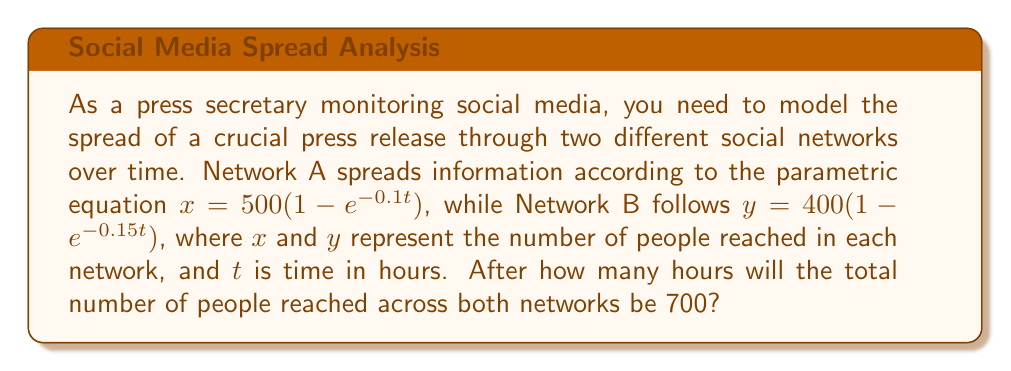Show me your answer to this math problem. To solve this problem, we need to follow these steps:

1) The total number of people reached is the sum of people reached in both networks:
   $x + y = 700$

2) Substitute the parametric equations:
   $500(1-e^{-0.1t}) + 400(1-e^{-0.15t}) = 700$

3) This equation can't be solved algebraically, so we need to use numerical methods. We can use a graphing calculator or a computer program to plot the left side of the equation and find where it intersects with y = 700.

4) Alternatively, we can use an iterative method like the Newton-Raphson method. Let's define:

   $f(t) = 500(1-e^{-0.1t}) + 400(1-e^{-0.15t}) - 700$

   We want to find where $f(t) = 0$.

5) The derivative of $f(t)$ is:

   $f'(t) = 50e^{-0.1t} + 60e^{-0.15t}$

6) Starting with an initial guess $t_0 = 5$, we can iterate:

   $t_{n+1} = t_n - \frac{f(t_n)}{f'(t_n)}$

7) After several iterations, this converges to approximately $t = 4.6861$ hours.

8) We can verify this by plugging it back into our original equations:

   $x = 500(1-e^{-0.1(4.6861)}) \approx 416.7$
   $y = 400(1-e^{-0.15(4.6861)}) \approx 283.3$

   $416.7 + 283.3 = 700$

Therefore, it will take approximately 4.69 hours for the total reach to be 700 people.
Answer: Approximately 4.69 hours 